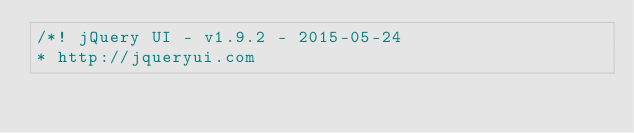Convert code to text. <code><loc_0><loc_0><loc_500><loc_500><_JavaScript_>/*! jQuery UI - v1.9.2 - 2015-05-24
* http://jqueryui.com</code> 